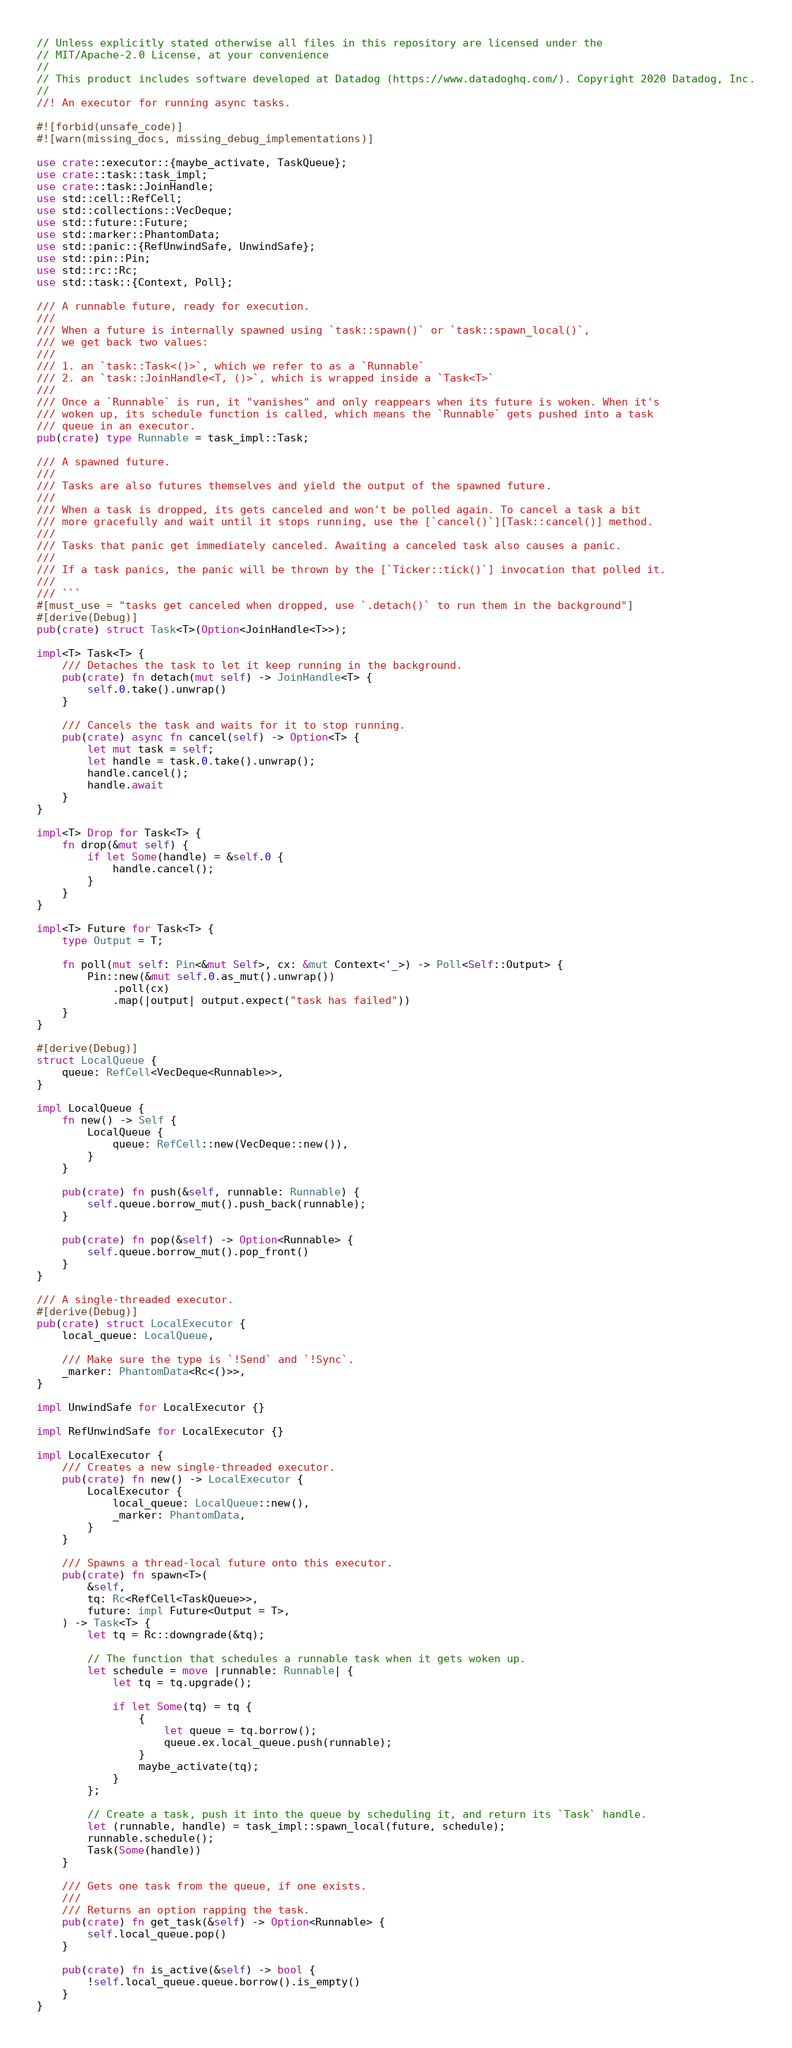<code> <loc_0><loc_0><loc_500><loc_500><_Rust_>// Unless explicitly stated otherwise all files in this repository are licensed under the
// MIT/Apache-2.0 License, at your convenience
//
// This product includes software developed at Datadog (https://www.datadoghq.com/). Copyright 2020 Datadog, Inc.
//
//! An executor for running async tasks.

#![forbid(unsafe_code)]
#![warn(missing_docs, missing_debug_implementations)]

use crate::executor::{maybe_activate, TaskQueue};
use crate::task::task_impl;
use crate::task::JoinHandle;
use std::cell::RefCell;
use std::collections::VecDeque;
use std::future::Future;
use std::marker::PhantomData;
use std::panic::{RefUnwindSafe, UnwindSafe};
use std::pin::Pin;
use std::rc::Rc;
use std::task::{Context, Poll};

/// A runnable future, ready for execution.
///
/// When a future is internally spawned using `task::spawn()` or `task::spawn_local()`,
/// we get back two values:
///
/// 1. an `task::Task<()>`, which we refer to as a `Runnable`
/// 2. an `task::JoinHandle<T, ()>`, which is wrapped inside a `Task<T>`
///
/// Once a `Runnable` is run, it "vanishes" and only reappears when its future is woken. When it's
/// woken up, its schedule function is called, which means the `Runnable` gets pushed into a task
/// queue in an executor.
pub(crate) type Runnable = task_impl::Task;

/// A spawned future.
///
/// Tasks are also futures themselves and yield the output of the spawned future.
///
/// When a task is dropped, its gets canceled and won't be polled again. To cancel a task a bit
/// more gracefully and wait until it stops running, use the [`cancel()`][Task::cancel()] method.
///
/// Tasks that panic get immediately canceled. Awaiting a canceled task also causes a panic.
///
/// If a task panics, the panic will be thrown by the [`Ticker::tick()`] invocation that polled it.
///
/// ```
#[must_use = "tasks get canceled when dropped, use `.detach()` to run them in the background"]
#[derive(Debug)]
pub(crate) struct Task<T>(Option<JoinHandle<T>>);

impl<T> Task<T> {
    /// Detaches the task to let it keep running in the background.
    pub(crate) fn detach(mut self) -> JoinHandle<T> {
        self.0.take().unwrap()
    }

    /// Cancels the task and waits for it to stop running.
    pub(crate) async fn cancel(self) -> Option<T> {
        let mut task = self;
        let handle = task.0.take().unwrap();
        handle.cancel();
        handle.await
    }
}

impl<T> Drop for Task<T> {
    fn drop(&mut self) {
        if let Some(handle) = &self.0 {
            handle.cancel();
        }
    }
}

impl<T> Future for Task<T> {
    type Output = T;

    fn poll(mut self: Pin<&mut Self>, cx: &mut Context<'_>) -> Poll<Self::Output> {
        Pin::new(&mut self.0.as_mut().unwrap())
            .poll(cx)
            .map(|output| output.expect("task has failed"))
    }
}

#[derive(Debug)]
struct LocalQueue {
    queue: RefCell<VecDeque<Runnable>>,
}

impl LocalQueue {
    fn new() -> Self {
        LocalQueue {
            queue: RefCell::new(VecDeque::new()),
        }
    }

    pub(crate) fn push(&self, runnable: Runnable) {
        self.queue.borrow_mut().push_back(runnable);
    }

    pub(crate) fn pop(&self) -> Option<Runnable> {
        self.queue.borrow_mut().pop_front()
    }
}

/// A single-threaded executor.
#[derive(Debug)]
pub(crate) struct LocalExecutor {
    local_queue: LocalQueue,

    /// Make sure the type is `!Send` and `!Sync`.
    _marker: PhantomData<Rc<()>>,
}

impl UnwindSafe for LocalExecutor {}

impl RefUnwindSafe for LocalExecutor {}

impl LocalExecutor {
    /// Creates a new single-threaded executor.
    pub(crate) fn new() -> LocalExecutor {
        LocalExecutor {
            local_queue: LocalQueue::new(),
            _marker: PhantomData,
        }
    }

    /// Spawns a thread-local future onto this executor.
    pub(crate) fn spawn<T>(
        &self,
        tq: Rc<RefCell<TaskQueue>>,
        future: impl Future<Output = T>,
    ) -> Task<T> {
        let tq = Rc::downgrade(&tq);

        // The function that schedules a runnable task when it gets woken up.
        let schedule = move |runnable: Runnable| {
            let tq = tq.upgrade();

            if let Some(tq) = tq {
                {
                    let queue = tq.borrow();
                    queue.ex.local_queue.push(runnable);
                }
                maybe_activate(tq);
            }
        };

        // Create a task, push it into the queue by scheduling it, and return its `Task` handle.
        let (runnable, handle) = task_impl::spawn_local(future, schedule);
        runnable.schedule();
        Task(Some(handle))
    }

    /// Gets one task from the queue, if one exists.
    ///
    /// Returns an option rapping the task.
    pub(crate) fn get_task(&self) -> Option<Runnable> {
        self.local_queue.pop()
    }

    pub(crate) fn is_active(&self) -> bool {
        !self.local_queue.queue.borrow().is_empty()
    }
}
</code> 